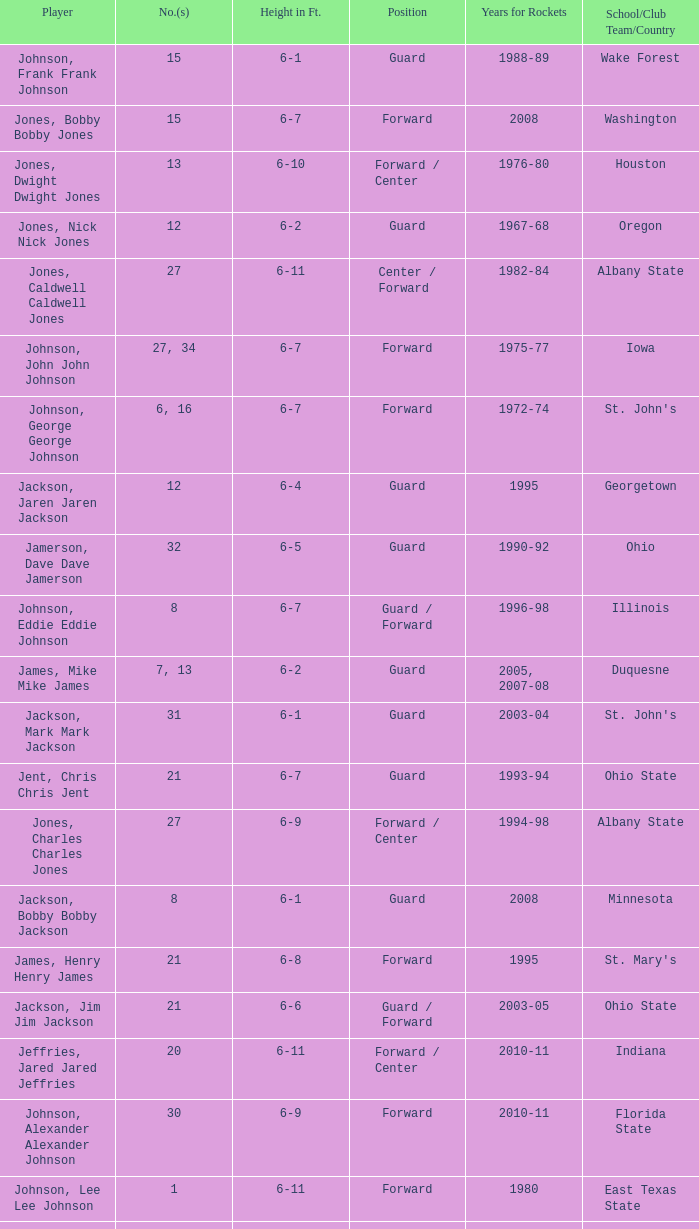Can you parse all the data within this table? {'header': ['Player', 'No.(s)', 'Height in Ft.', 'Position', 'Years for Rockets', 'School/Club Team/Country'], 'rows': [['Johnson, Frank Frank Johnson', '15', '6-1', 'Guard', '1988-89', 'Wake Forest'], ['Jones, Bobby Bobby Jones', '15', '6-7', 'Forward', '2008', 'Washington'], ['Jones, Dwight Dwight Jones', '13', '6-10', 'Forward / Center', '1976-80', 'Houston'], ['Jones, Nick Nick Jones', '12', '6-2', 'Guard', '1967-68', 'Oregon'], ['Jones, Caldwell Caldwell Jones', '27', '6-11', 'Center / Forward', '1982-84', 'Albany State'], ['Johnson, John John Johnson', '27, 34', '6-7', 'Forward', '1975-77', 'Iowa'], ['Johnson, George George Johnson', '6, 16', '6-7', 'Forward', '1972-74', "St. John's"], ['Jackson, Jaren Jaren Jackson', '12', '6-4', 'Guard', '1995', 'Georgetown'], ['Jamerson, Dave Dave Jamerson', '32', '6-5', 'Guard', '1990-92', 'Ohio'], ['Johnson, Eddie Eddie Johnson', '8', '6-7', 'Guard / Forward', '1996-98', 'Illinois'], ['James, Mike Mike James', '7, 13', '6-2', 'Guard', '2005, 2007-08', 'Duquesne'], ['Jackson, Mark Mark Jackson', '31', '6-1', 'Guard', '2003-04', "St. John's"], ['Jent, Chris Chris Jent', '21', '6-7', 'Guard', '1993-94', 'Ohio State'], ['Jones, Charles Charles Jones', '27', '6-9', 'Forward / Center', '1994-98', 'Albany State'], ['Jackson, Bobby Bobby Jackson', '8', '6-1', 'Guard', '2008', 'Minnesota'], ['James, Henry Henry James', '21', '6-8', 'Forward', '1995', "St. Mary's"], ['Jackson, Jim Jim Jackson', '21', '6-6', 'Guard / Forward', '2003-05', 'Ohio State'], ['Jeffries, Jared Jared Jeffries', '20', '6-11', 'Forward / Center', '2010-11', 'Indiana'], ['Johnson, Alexander Alexander Johnson', '30', '6-9', 'Forward', '2010-11', 'Florida State'], ['Johnson, Lee Lee Johnson', '1', '6-11', 'Forward', '1980', 'East Texas State'], ['Jones, Major Major Jones', '11', '6-9', 'Forward / Center', '1979-84', 'Albany State'], ['Johnson, Buck Buck Johnson', '1', '6-7', 'Forward', '1986-92', 'Alabama'], ['Johnson, Avery Avery Johnson', '6', '5-11', 'Guard', '1991-92', 'Southern University']]} Which player who played for the Rockets for the years 1986-92? Johnson, Buck Buck Johnson. 